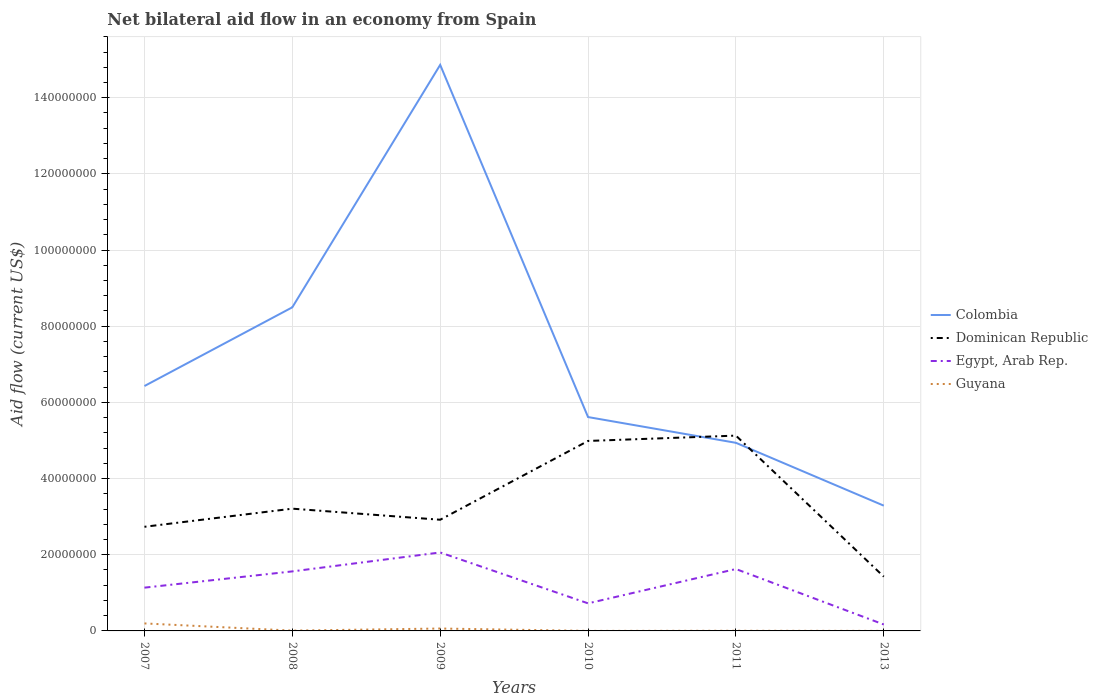How many different coloured lines are there?
Offer a very short reply. 4. Is the number of lines equal to the number of legend labels?
Make the answer very short. Yes. Across all years, what is the maximum net bilateral aid flow in Egypt, Arab Rep.?
Keep it short and to the point. 1.69e+06. What is the total net bilateral aid flow in Colombia in the graph?
Offer a very short reply. 3.56e+07. What is the difference between the highest and the second highest net bilateral aid flow in Egypt, Arab Rep.?
Keep it short and to the point. 1.89e+07. Is the net bilateral aid flow in Dominican Republic strictly greater than the net bilateral aid flow in Egypt, Arab Rep. over the years?
Make the answer very short. No. How many years are there in the graph?
Offer a terse response. 6. Are the values on the major ticks of Y-axis written in scientific E-notation?
Make the answer very short. No. Where does the legend appear in the graph?
Provide a succinct answer. Center right. How many legend labels are there?
Your answer should be compact. 4. How are the legend labels stacked?
Offer a very short reply. Vertical. What is the title of the graph?
Your answer should be compact. Net bilateral aid flow in an economy from Spain. Does "Sri Lanka" appear as one of the legend labels in the graph?
Provide a short and direct response. No. What is the label or title of the X-axis?
Provide a short and direct response. Years. What is the Aid flow (current US$) in Colombia in 2007?
Your answer should be compact. 6.43e+07. What is the Aid flow (current US$) of Dominican Republic in 2007?
Your answer should be compact. 2.73e+07. What is the Aid flow (current US$) of Egypt, Arab Rep. in 2007?
Your answer should be compact. 1.14e+07. What is the Aid flow (current US$) of Guyana in 2007?
Ensure brevity in your answer.  1.97e+06. What is the Aid flow (current US$) in Colombia in 2008?
Your answer should be very brief. 8.50e+07. What is the Aid flow (current US$) in Dominican Republic in 2008?
Your answer should be very brief. 3.21e+07. What is the Aid flow (current US$) of Egypt, Arab Rep. in 2008?
Make the answer very short. 1.56e+07. What is the Aid flow (current US$) of Colombia in 2009?
Your answer should be very brief. 1.49e+08. What is the Aid flow (current US$) in Dominican Republic in 2009?
Offer a very short reply. 2.92e+07. What is the Aid flow (current US$) in Egypt, Arab Rep. in 2009?
Your answer should be very brief. 2.06e+07. What is the Aid flow (current US$) in Guyana in 2009?
Offer a very short reply. 6.30e+05. What is the Aid flow (current US$) of Colombia in 2010?
Provide a short and direct response. 5.62e+07. What is the Aid flow (current US$) in Dominican Republic in 2010?
Your answer should be very brief. 4.99e+07. What is the Aid flow (current US$) in Egypt, Arab Rep. in 2010?
Ensure brevity in your answer.  7.24e+06. What is the Aid flow (current US$) in Colombia in 2011?
Ensure brevity in your answer.  4.94e+07. What is the Aid flow (current US$) of Dominican Republic in 2011?
Your answer should be very brief. 5.13e+07. What is the Aid flow (current US$) of Egypt, Arab Rep. in 2011?
Your answer should be very brief. 1.62e+07. What is the Aid flow (current US$) in Colombia in 2013?
Your answer should be compact. 3.29e+07. What is the Aid flow (current US$) of Dominican Republic in 2013?
Ensure brevity in your answer.  1.42e+07. What is the Aid flow (current US$) in Egypt, Arab Rep. in 2013?
Provide a succinct answer. 1.69e+06. What is the Aid flow (current US$) of Guyana in 2013?
Provide a short and direct response. 10000. Across all years, what is the maximum Aid flow (current US$) in Colombia?
Give a very brief answer. 1.49e+08. Across all years, what is the maximum Aid flow (current US$) in Dominican Republic?
Your answer should be compact. 5.13e+07. Across all years, what is the maximum Aid flow (current US$) of Egypt, Arab Rep.?
Ensure brevity in your answer.  2.06e+07. Across all years, what is the maximum Aid flow (current US$) of Guyana?
Offer a terse response. 1.97e+06. Across all years, what is the minimum Aid flow (current US$) in Colombia?
Your answer should be very brief. 3.29e+07. Across all years, what is the minimum Aid flow (current US$) of Dominican Republic?
Give a very brief answer. 1.42e+07. Across all years, what is the minimum Aid flow (current US$) in Egypt, Arab Rep.?
Ensure brevity in your answer.  1.69e+06. What is the total Aid flow (current US$) of Colombia in the graph?
Keep it short and to the point. 4.36e+08. What is the total Aid flow (current US$) in Dominican Republic in the graph?
Provide a succinct answer. 2.04e+08. What is the total Aid flow (current US$) in Egypt, Arab Rep. in the graph?
Keep it short and to the point. 7.28e+07. What is the total Aid flow (current US$) of Guyana in the graph?
Offer a terse response. 2.74e+06. What is the difference between the Aid flow (current US$) in Colombia in 2007 and that in 2008?
Provide a short and direct response. -2.07e+07. What is the difference between the Aid flow (current US$) of Dominican Republic in 2007 and that in 2008?
Provide a succinct answer. -4.76e+06. What is the difference between the Aid flow (current US$) of Egypt, Arab Rep. in 2007 and that in 2008?
Make the answer very short. -4.27e+06. What is the difference between the Aid flow (current US$) in Guyana in 2007 and that in 2008?
Provide a succinct answer. 1.89e+06. What is the difference between the Aid flow (current US$) in Colombia in 2007 and that in 2009?
Your response must be concise. -8.43e+07. What is the difference between the Aid flow (current US$) in Dominican Republic in 2007 and that in 2009?
Your response must be concise. -1.85e+06. What is the difference between the Aid flow (current US$) of Egypt, Arab Rep. in 2007 and that in 2009?
Offer a terse response. -9.24e+06. What is the difference between the Aid flow (current US$) in Guyana in 2007 and that in 2009?
Your response must be concise. 1.34e+06. What is the difference between the Aid flow (current US$) in Colombia in 2007 and that in 2010?
Offer a terse response. 8.15e+06. What is the difference between the Aid flow (current US$) of Dominican Republic in 2007 and that in 2010?
Your answer should be compact. -2.25e+07. What is the difference between the Aid flow (current US$) of Egypt, Arab Rep. in 2007 and that in 2010?
Offer a terse response. 4.12e+06. What is the difference between the Aid flow (current US$) of Guyana in 2007 and that in 2010?
Your answer should be very brief. 1.96e+06. What is the difference between the Aid flow (current US$) in Colombia in 2007 and that in 2011?
Keep it short and to the point. 1.49e+07. What is the difference between the Aid flow (current US$) of Dominican Republic in 2007 and that in 2011?
Your answer should be very brief. -2.39e+07. What is the difference between the Aid flow (current US$) of Egypt, Arab Rep. in 2007 and that in 2011?
Keep it short and to the point. -4.89e+06. What is the difference between the Aid flow (current US$) of Guyana in 2007 and that in 2011?
Provide a short and direct response. 1.93e+06. What is the difference between the Aid flow (current US$) in Colombia in 2007 and that in 2013?
Ensure brevity in your answer.  3.14e+07. What is the difference between the Aid flow (current US$) of Dominican Republic in 2007 and that in 2013?
Make the answer very short. 1.31e+07. What is the difference between the Aid flow (current US$) of Egypt, Arab Rep. in 2007 and that in 2013?
Provide a succinct answer. 9.67e+06. What is the difference between the Aid flow (current US$) of Guyana in 2007 and that in 2013?
Ensure brevity in your answer.  1.96e+06. What is the difference between the Aid flow (current US$) of Colombia in 2008 and that in 2009?
Your answer should be compact. -6.36e+07. What is the difference between the Aid flow (current US$) in Dominican Republic in 2008 and that in 2009?
Make the answer very short. 2.91e+06. What is the difference between the Aid flow (current US$) of Egypt, Arab Rep. in 2008 and that in 2009?
Offer a terse response. -4.97e+06. What is the difference between the Aid flow (current US$) of Guyana in 2008 and that in 2009?
Your response must be concise. -5.50e+05. What is the difference between the Aid flow (current US$) in Colombia in 2008 and that in 2010?
Provide a short and direct response. 2.88e+07. What is the difference between the Aid flow (current US$) of Dominican Republic in 2008 and that in 2010?
Your answer should be very brief. -1.78e+07. What is the difference between the Aid flow (current US$) of Egypt, Arab Rep. in 2008 and that in 2010?
Offer a terse response. 8.39e+06. What is the difference between the Aid flow (current US$) in Guyana in 2008 and that in 2010?
Provide a short and direct response. 7.00e+04. What is the difference between the Aid flow (current US$) in Colombia in 2008 and that in 2011?
Make the answer very short. 3.56e+07. What is the difference between the Aid flow (current US$) of Dominican Republic in 2008 and that in 2011?
Your response must be concise. -1.92e+07. What is the difference between the Aid flow (current US$) in Egypt, Arab Rep. in 2008 and that in 2011?
Offer a very short reply. -6.20e+05. What is the difference between the Aid flow (current US$) in Colombia in 2008 and that in 2013?
Keep it short and to the point. 5.21e+07. What is the difference between the Aid flow (current US$) in Dominican Republic in 2008 and that in 2013?
Give a very brief answer. 1.78e+07. What is the difference between the Aid flow (current US$) of Egypt, Arab Rep. in 2008 and that in 2013?
Give a very brief answer. 1.39e+07. What is the difference between the Aid flow (current US$) of Colombia in 2009 and that in 2010?
Your answer should be very brief. 9.25e+07. What is the difference between the Aid flow (current US$) of Dominican Republic in 2009 and that in 2010?
Your response must be concise. -2.07e+07. What is the difference between the Aid flow (current US$) in Egypt, Arab Rep. in 2009 and that in 2010?
Ensure brevity in your answer.  1.34e+07. What is the difference between the Aid flow (current US$) of Guyana in 2009 and that in 2010?
Offer a terse response. 6.20e+05. What is the difference between the Aid flow (current US$) of Colombia in 2009 and that in 2011?
Your answer should be compact. 9.92e+07. What is the difference between the Aid flow (current US$) in Dominican Republic in 2009 and that in 2011?
Provide a short and direct response. -2.21e+07. What is the difference between the Aid flow (current US$) of Egypt, Arab Rep. in 2009 and that in 2011?
Offer a very short reply. 4.35e+06. What is the difference between the Aid flow (current US$) of Guyana in 2009 and that in 2011?
Offer a very short reply. 5.90e+05. What is the difference between the Aid flow (current US$) of Colombia in 2009 and that in 2013?
Make the answer very short. 1.16e+08. What is the difference between the Aid flow (current US$) in Dominican Republic in 2009 and that in 2013?
Your answer should be compact. 1.49e+07. What is the difference between the Aid flow (current US$) of Egypt, Arab Rep. in 2009 and that in 2013?
Provide a short and direct response. 1.89e+07. What is the difference between the Aid flow (current US$) of Guyana in 2009 and that in 2013?
Your answer should be very brief. 6.20e+05. What is the difference between the Aid flow (current US$) of Colombia in 2010 and that in 2011?
Make the answer very short. 6.76e+06. What is the difference between the Aid flow (current US$) in Dominican Republic in 2010 and that in 2011?
Ensure brevity in your answer.  -1.40e+06. What is the difference between the Aid flow (current US$) of Egypt, Arab Rep. in 2010 and that in 2011?
Ensure brevity in your answer.  -9.01e+06. What is the difference between the Aid flow (current US$) in Guyana in 2010 and that in 2011?
Provide a short and direct response. -3.00e+04. What is the difference between the Aid flow (current US$) of Colombia in 2010 and that in 2013?
Your answer should be very brief. 2.33e+07. What is the difference between the Aid flow (current US$) in Dominican Republic in 2010 and that in 2013?
Give a very brief answer. 3.56e+07. What is the difference between the Aid flow (current US$) of Egypt, Arab Rep. in 2010 and that in 2013?
Keep it short and to the point. 5.55e+06. What is the difference between the Aid flow (current US$) of Colombia in 2011 and that in 2013?
Provide a short and direct response. 1.65e+07. What is the difference between the Aid flow (current US$) of Dominican Republic in 2011 and that in 2013?
Provide a short and direct response. 3.70e+07. What is the difference between the Aid flow (current US$) in Egypt, Arab Rep. in 2011 and that in 2013?
Your response must be concise. 1.46e+07. What is the difference between the Aid flow (current US$) of Colombia in 2007 and the Aid flow (current US$) of Dominican Republic in 2008?
Offer a very short reply. 3.22e+07. What is the difference between the Aid flow (current US$) of Colombia in 2007 and the Aid flow (current US$) of Egypt, Arab Rep. in 2008?
Your answer should be very brief. 4.87e+07. What is the difference between the Aid flow (current US$) of Colombia in 2007 and the Aid flow (current US$) of Guyana in 2008?
Offer a terse response. 6.42e+07. What is the difference between the Aid flow (current US$) of Dominican Republic in 2007 and the Aid flow (current US$) of Egypt, Arab Rep. in 2008?
Keep it short and to the point. 1.17e+07. What is the difference between the Aid flow (current US$) of Dominican Republic in 2007 and the Aid flow (current US$) of Guyana in 2008?
Your answer should be very brief. 2.73e+07. What is the difference between the Aid flow (current US$) of Egypt, Arab Rep. in 2007 and the Aid flow (current US$) of Guyana in 2008?
Offer a terse response. 1.13e+07. What is the difference between the Aid flow (current US$) in Colombia in 2007 and the Aid flow (current US$) in Dominican Republic in 2009?
Make the answer very short. 3.51e+07. What is the difference between the Aid flow (current US$) of Colombia in 2007 and the Aid flow (current US$) of Egypt, Arab Rep. in 2009?
Offer a terse response. 4.37e+07. What is the difference between the Aid flow (current US$) in Colombia in 2007 and the Aid flow (current US$) in Guyana in 2009?
Your answer should be very brief. 6.37e+07. What is the difference between the Aid flow (current US$) of Dominican Republic in 2007 and the Aid flow (current US$) of Egypt, Arab Rep. in 2009?
Offer a terse response. 6.74e+06. What is the difference between the Aid flow (current US$) in Dominican Republic in 2007 and the Aid flow (current US$) in Guyana in 2009?
Make the answer very short. 2.67e+07. What is the difference between the Aid flow (current US$) in Egypt, Arab Rep. in 2007 and the Aid flow (current US$) in Guyana in 2009?
Offer a very short reply. 1.07e+07. What is the difference between the Aid flow (current US$) of Colombia in 2007 and the Aid flow (current US$) of Dominican Republic in 2010?
Offer a very short reply. 1.44e+07. What is the difference between the Aid flow (current US$) in Colombia in 2007 and the Aid flow (current US$) in Egypt, Arab Rep. in 2010?
Ensure brevity in your answer.  5.71e+07. What is the difference between the Aid flow (current US$) in Colombia in 2007 and the Aid flow (current US$) in Guyana in 2010?
Keep it short and to the point. 6.43e+07. What is the difference between the Aid flow (current US$) in Dominican Republic in 2007 and the Aid flow (current US$) in Egypt, Arab Rep. in 2010?
Keep it short and to the point. 2.01e+07. What is the difference between the Aid flow (current US$) of Dominican Republic in 2007 and the Aid flow (current US$) of Guyana in 2010?
Give a very brief answer. 2.73e+07. What is the difference between the Aid flow (current US$) of Egypt, Arab Rep. in 2007 and the Aid flow (current US$) of Guyana in 2010?
Provide a succinct answer. 1.14e+07. What is the difference between the Aid flow (current US$) of Colombia in 2007 and the Aid flow (current US$) of Dominican Republic in 2011?
Your response must be concise. 1.30e+07. What is the difference between the Aid flow (current US$) in Colombia in 2007 and the Aid flow (current US$) in Egypt, Arab Rep. in 2011?
Offer a very short reply. 4.80e+07. What is the difference between the Aid flow (current US$) of Colombia in 2007 and the Aid flow (current US$) of Guyana in 2011?
Your answer should be compact. 6.43e+07. What is the difference between the Aid flow (current US$) of Dominican Republic in 2007 and the Aid flow (current US$) of Egypt, Arab Rep. in 2011?
Offer a terse response. 1.11e+07. What is the difference between the Aid flow (current US$) in Dominican Republic in 2007 and the Aid flow (current US$) in Guyana in 2011?
Offer a very short reply. 2.73e+07. What is the difference between the Aid flow (current US$) in Egypt, Arab Rep. in 2007 and the Aid flow (current US$) in Guyana in 2011?
Ensure brevity in your answer.  1.13e+07. What is the difference between the Aid flow (current US$) in Colombia in 2007 and the Aid flow (current US$) in Dominican Republic in 2013?
Offer a very short reply. 5.00e+07. What is the difference between the Aid flow (current US$) in Colombia in 2007 and the Aid flow (current US$) in Egypt, Arab Rep. in 2013?
Make the answer very short. 6.26e+07. What is the difference between the Aid flow (current US$) of Colombia in 2007 and the Aid flow (current US$) of Guyana in 2013?
Provide a succinct answer. 6.43e+07. What is the difference between the Aid flow (current US$) of Dominican Republic in 2007 and the Aid flow (current US$) of Egypt, Arab Rep. in 2013?
Provide a succinct answer. 2.56e+07. What is the difference between the Aid flow (current US$) in Dominican Republic in 2007 and the Aid flow (current US$) in Guyana in 2013?
Give a very brief answer. 2.73e+07. What is the difference between the Aid flow (current US$) of Egypt, Arab Rep. in 2007 and the Aid flow (current US$) of Guyana in 2013?
Ensure brevity in your answer.  1.14e+07. What is the difference between the Aid flow (current US$) of Colombia in 2008 and the Aid flow (current US$) of Dominican Republic in 2009?
Your response must be concise. 5.58e+07. What is the difference between the Aid flow (current US$) in Colombia in 2008 and the Aid flow (current US$) in Egypt, Arab Rep. in 2009?
Give a very brief answer. 6.44e+07. What is the difference between the Aid flow (current US$) of Colombia in 2008 and the Aid flow (current US$) of Guyana in 2009?
Offer a very short reply. 8.43e+07. What is the difference between the Aid flow (current US$) in Dominican Republic in 2008 and the Aid flow (current US$) in Egypt, Arab Rep. in 2009?
Provide a succinct answer. 1.15e+07. What is the difference between the Aid flow (current US$) in Dominican Republic in 2008 and the Aid flow (current US$) in Guyana in 2009?
Ensure brevity in your answer.  3.15e+07. What is the difference between the Aid flow (current US$) of Egypt, Arab Rep. in 2008 and the Aid flow (current US$) of Guyana in 2009?
Provide a short and direct response. 1.50e+07. What is the difference between the Aid flow (current US$) of Colombia in 2008 and the Aid flow (current US$) of Dominican Republic in 2010?
Your answer should be compact. 3.51e+07. What is the difference between the Aid flow (current US$) of Colombia in 2008 and the Aid flow (current US$) of Egypt, Arab Rep. in 2010?
Offer a very short reply. 7.77e+07. What is the difference between the Aid flow (current US$) of Colombia in 2008 and the Aid flow (current US$) of Guyana in 2010?
Make the answer very short. 8.50e+07. What is the difference between the Aid flow (current US$) in Dominican Republic in 2008 and the Aid flow (current US$) in Egypt, Arab Rep. in 2010?
Your answer should be very brief. 2.49e+07. What is the difference between the Aid flow (current US$) in Dominican Republic in 2008 and the Aid flow (current US$) in Guyana in 2010?
Give a very brief answer. 3.21e+07. What is the difference between the Aid flow (current US$) of Egypt, Arab Rep. in 2008 and the Aid flow (current US$) of Guyana in 2010?
Provide a short and direct response. 1.56e+07. What is the difference between the Aid flow (current US$) of Colombia in 2008 and the Aid flow (current US$) of Dominican Republic in 2011?
Make the answer very short. 3.37e+07. What is the difference between the Aid flow (current US$) in Colombia in 2008 and the Aid flow (current US$) in Egypt, Arab Rep. in 2011?
Keep it short and to the point. 6.87e+07. What is the difference between the Aid flow (current US$) in Colombia in 2008 and the Aid flow (current US$) in Guyana in 2011?
Your answer should be compact. 8.49e+07. What is the difference between the Aid flow (current US$) in Dominican Republic in 2008 and the Aid flow (current US$) in Egypt, Arab Rep. in 2011?
Ensure brevity in your answer.  1.58e+07. What is the difference between the Aid flow (current US$) in Dominican Republic in 2008 and the Aid flow (current US$) in Guyana in 2011?
Give a very brief answer. 3.21e+07. What is the difference between the Aid flow (current US$) of Egypt, Arab Rep. in 2008 and the Aid flow (current US$) of Guyana in 2011?
Your answer should be compact. 1.56e+07. What is the difference between the Aid flow (current US$) in Colombia in 2008 and the Aid flow (current US$) in Dominican Republic in 2013?
Offer a very short reply. 7.07e+07. What is the difference between the Aid flow (current US$) of Colombia in 2008 and the Aid flow (current US$) of Egypt, Arab Rep. in 2013?
Ensure brevity in your answer.  8.33e+07. What is the difference between the Aid flow (current US$) of Colombia in 2008 and the Aid flow (current US$) of Guyana in 2013?
Keep it short and to the point. 8.50e+07. What is the difference between the Aid flow (current US$) of Dominican Republic in 2008 and the Aid flow (current US$) of Egypt, Arab Rep. in 2013?
Offer a very short reply. 3.04e+07. What is the difference between the Aid flow (current US$) in Dominican Republic in 2008 and the Aid flow (current US$) in Guyana in 2013?
Give a very brief answer. 3.21e+07. What is the difference between the Aid flow (current US$) in Egypt, Arab Rep. in 2008 and the Aid flow (current US$) in Guyana in 2013?
Keep it short and to the point. 1.56e+07. What is the difference between the Aid flow (current US$) in Colombia in 2009 and the Aid flow (current US$) in Dominican Republic in 2010?
Your answer should be very brief. 9.87e+07. What is the difference between the Aid flow (current US$) of Colombia in 2009 and the Aid flow (current US$) of Egypt, Arab Rep. in 2010?
Ensure brevity in your answer.  1.41e+08. What is the difference between the Aid flow (current US$) of Colombia in 2009 and the Aid flow (current US$) of Guyana in 2010?
Your response must be concise. 1.49e+08. What is the difference between the Aid flow (current US$) in Dominican Republic in 2009 and the Aid flow (current US$) in Egypt, Arab Rep. in 2010?
Provide a short and direct response. 2.20e+07. What is the difference between the Aid flow (current US$) in Dominican Republic in 2009 and the Aid flow (current US$) in Guyana in 2010?
Make the answer very short. 2.92e+07. What is the difference between the Aid flow (current US$) in Egypt, Arab Rep. in 2009 and the Aid flow (current US$) in Guyana in 2010?
Offer a very short reply. 2.06e+07. What is the difference between the Aid flow (current US$) in Colombia in 2009 and the Aid flow (current US$) in Dominican Republic in 2011?
Provide a short and direct response. 9.73e+07. What is the difference between the Aid flow (current US$) in Colombia in 2009 and the Aid flow (current US$) in Egypt, Arab Rep. in 2011?
Ensure brevity in your answer.  1.32e+08. What is the difference between the Aid flow (current US$) of Colombia in 2009 and the Aid flow (current US$) of Guyana in 2011?
Provide a succinct answer. 1.49e+08. What is the difference between the Aid flow (current US$) of Dominican Republic in 2009 and the Aid flow (current US$) of Egypt, Arab Rep. in 2011?
Your answer should be compact. 1.29e+07. What is the difference between the Aid flow (current US$) of Dominican Republic in 2009 and the Aid flow (current US$) of Guyana in 2011?
Your answer should be compact. 2.92e+07. What is the difference between the Aid flow (current US$) of Egypt, Arab Rep. in 2009 and the Aid flow (current US$) of Guyana in 2011?
Your answer should be very brief. 2.06e+07. What is the difference between the Aid flow (current US$) of Colombia in 2009 and the Aid flow (current US$) of Dominican Republic in 2013?
Your answer should be compact. 1.34e+08. What is the difference between the Aid flow (current US$) in Colombia in 2009 and the Aid flow (current US$) in Egypt, Arab Rep. in 2013?
Your answer should be very brief. 1.47e+08. What is the difference between the Aid flow (current US$) in Colombia in 2009 and the Aid flow (current US$) in Guyana in 2013?
Provide a short and direct response. 1.49e+08. What is the difference between the Aid flow (current US$) in Dominican Republic in 2009 and the Aid flow (current US$) in Egypt, Arab Rep. in 2013?
Make the answer very short. 2.75e+07. What is the difference between the Aid flow (current US$) in Dominican Republic in 2009 and the Aid flow (current US$) in Guyana in 2013?
Give a very brief answer. 2.92e+07. What is the difference between the Aid flow (current US$) in Egypt, Arab Rep. in 2009 and the Aid flow (current US$) in Guyana in 2013?
Provide a short and direct response. 2.06e+07. What is the difference between the Aid flow (current US$) in Colombia in 2010 and the Aid flow (current US$) in Dominican Republic in 2011?
Make the answer very short. 4.87e+06. What is the difference between the Aid flow (current US$) of Colombia in 2010 and the Aid flow (current US$) of Egypt, Arab Rep. in 2011?
Your response must be concise. 3.99e+07. What is the difference between the Aid flow (current US$) in Colombia in 2010 and the Aid flow (current US$) in Guyana in 2011?
Provide a succinct answer. 5.61e+07. What is the difference between the Aid flow (current US$) in Dominican Republic in 2010 and the Aid flow (current US$) in Egypt, Arab Rep. in 2011?
Ensure brevity in your answer.  3.36e+07. What is the difference between the Aid flow (current US$) of Dominican Republic in 2010 and the Aid flow (current US$) of Guyana in 2011?
Your answer should be very brief. 4.98e+07. What is the difference between the Aid flow (current US$) in Egypt, Arab Rep. in 2010 and the Aid flow (current US$) in Guyana in 2011?
Provide a short and direct response. 7.20e+06. What is the difference between the Aid flow (current US$) of Colombia in 2010 and the Aid flow (current US$) of Dominican Republic in 2013?
Offer a very short reply. 4.19e+07. What is the difference between the Aid flow (current US$) in Colombia in 2010 and the Aid flow (current US$) in Egypt, Arab Rep. in 2013?
Your answer should be compact. 5.45e+07. What is the difference between the Aid flow (current US$) of Colombia in 2010 and the Aid flow (current US$) of Guyana in 2013?
Your answer should be compact. 5.61e+07. What is the difference between the Aid flow (current US$) in Dominican Republic in 2010 and the Aid flow (current US$) in Egypt, Arab Rep. in 2013?
Keep it short and to the point. 4.82e+07. What is the difference between the Aid flow (current US$) in Dominican Republic in 2010 and the Aid flow (current US$) in Guyana in 2013?
Your answer should be compact. 4.99e+07. What is the difference between the Aid flow (current US$) in Egypt, Arab Rep. in 2010 and the Aid flow (current US$) in Guyana in 2013?
Your answer should be very brief. 7.23e+06. What is the difference between the Aid flow (current US$) of Colombia in 2011 and the Aid flow (current US$) of Dominican Republic in 2013?
Your answer should be compact. 3.51e+07. What is the difference between the Aid flow (current US$) of Colombia in 2011 and the Aid flow (current US$) of Egypt, Arab Rep. in 2013?
Ensure brevity in your answer.  4.77e+07. What is the difference between the Aid flow (current US$) of Colombia in 2011 and the Aid flow (current US$) of Guyana in 2013?
Your response must be concise. 4.94e+07. What is the difference between the Aid flow (current US$) in Dominican Republic in 2011 and the Aid flow (current US$) in Egypt, Arab Rep. in 2013?
Your response must be concise. 4.96e+07. What is the difference between the Aid flow (current US$) in Dominican Republic in 2011 and the Aid flow (current US$) in Guyana in 2013?
Your answer should be very brief. 5.13e+07. What is the difference between the Aid flow (current US$) in Egypt, Arab Rep. in 2011 and the Aid flow (current US$) in Guyana in 2013?
Offer a terse response. 1.62e+07. What is the average Aid flow (current US$) of Colombia per year?
Provide a succinct answer. 7.27e+07. What is the average Aid flow (current US$) in Dominican Republic per year?
Provide a succinct answer. 3.40e+07. What is the average Aid flow (current US$) in Egypt, Arab Rep. per year?
Keep it short and to the point. 1.21e+07. What is the average Aid flow (current US$) in Guyana per year?
Provide a short and direct response. 4.57e+05. In the year 2007, what is the difference between the Aid flow (current US$) of Colombia and Aid flow (current US$) of Dominican Republic?
Provide a succinct answer. 3.70e+07. In the year 2007, what is the difference between the Aid flow (current US$) in Colombia and Aid flow (current US$) in Egypt, Arab Rep.?
Your response must be concise. 5.29e+07. In the year 2007, what is the difference between the Aid flow (current US$) of Colombia and Aid flow (current US$) of Guyana?
Your answer should be very brief. 6.23e+07. In the year 2007, what is the difference between the Aid flow (current US$) in Dominican Republic and Aid flow (current US$) in Egypt, Arab Rep.?
Offer a terse response. 1.60e+07. In the year 2007, what is the difference between the Aid flow (current US$) of Dominican Republic and Aid flow (current US$) of Guyana?
Ensure brevity in your answer.  2.54e+07. In the year 2007, what is the difference between the Aid flow (current US$) in Egypt, Arab Rep. and Aid flow (current US$) in Guyana?
Provide a succinct answer. 9.39e+06. In the year 2008, what is the difference between the Aid flow (current US$) in Colombia and Aid flow (current US$) in Dominican Republic?
Make the answer very short. 5.29e+07. In the year 2008, what is the difference between the Aid flow (current US$) of Colombia and Aid flow (current US$) of Egypt, Arab Rep.?
Provide a succinct answer. 6.93e+07. In the year 2008, what is the difference between the Aid flow (current US$) of Colombia and Aid flow (current US$) of Guyana?
Your answer should be compact. 8.49e+07. In the year 2008, what is the difference between the Aid flow (current US$) of Dominican Republic and Aid flow (current US$) of Egypt, Arab Rep.?
Your answer should be compact. 1.65e+07. In the year 2008, what is the difference between the Aid flow (current US$) in Dominican Republic and Aid flow (current US$) in Guyana?
Provide a short and direct response. 3.20e+07. In the year 2008, what is the difference between the Aid flow (current US$) in Egypt, Arab Rep. and Aid flow (current US$) in Guyana?
Your answer should be very brief. 1.56e+07. In the year 2009, what is the difference between the Aid flow (current US$) of Colombia and Aid flow (current US$) of Dominican Republic?
Offer a terse response. 1.19e+08. In the year 2009, what is the difference between the Aid flow (current US$) of Colombia and Aid flow (current US$) of Egypt, Arab Rep.?
Your answer should be very brief. 1.28e+08. In the year 2009, what is the difference between the Aid flow (current US$) in Colombia and Aid flow (current US$) in Guyana?
Your answer should be very brief. 1.48e+08. In the year 2009, what is the difference between the Aid flow (current US$) in Dominican Republic and Aid flow (current US$) in Egypt, Arab Rep.?
Offer a terse response. 8.59e+06. In the year 2009, what is the difference between the Aid flow (current US$) of Dominican Republic and Aid flow (current US$) of Guyana?
Keep it short and to the point. 2.86e+07. In the year 2009, what is the difference between the Aid flow (current US$) in Egypt, Arab Rep. and Aid flow (current US$) in Guyana?
Your answer should be very brief. 2.00e+07. In the year 2010, what is the difference between the Aid flow (current US$) of Colombia and Aid flow (current US$) of Dominican Republic?
Offer a very short reply. 6.27e+06. In the year 2010, what is the difference between the Aid flow (current US$) in Colombia and Aid flow (current US$) in Egypt, Arab Rep.?
Provide a short and direct response. 4.89e+07. In the year 2010, what is the difference between the Aid flow (current US$) in Colombia and Aid flow (current US$) in Guyana?
Give a very brief answer. 5.61e+07. In the year 2010, what is the difference between the Aid flow (current US$) of Dominican Republic and Aid flow (current US$) of Egypt, Arab Rep.?
Ensure brevity in your answer.  4.26e+07. In the year 2010, what is the difference between the Aid flow (current US$) in Dominican Republic and Aid flow (current US$) in Guyana?
Provide a succinct answer. 4.99e+07. In the year 2010, what is the difference between the Aid flow (current US$) of Egypt, Arab Rep. and Aid flow (current US$) of Guyana?
Give a very brief answer. 7.23e+06. In the year 2011, what is the difference between the Aid flow (current US$) of Colombia and Aid flow (current US$) of Dominican Republic?
Offer a terse response. -1.89e+06. In the year 2011, what is the difference between the Aid flow (current US$) of Colombia and Aid flow (current US$) of Egypt, Arab Rep.?
Your answer should be very brief. 3.31e+07. In the year 2011, what is the difference between the Aid flow (current US$) of Colombia and Aid flow (current US$) of Guyana?
Offer a very short reply. 4.94e+07. In the year 2011, what is the difference between the Aid flow (current US$) of Dominican Republic and Aid flow (current US$) of Egypt, Arab Rep.?
Your answer should be compact. 3.50e+07. In the year 2011, what is the difference between the Aid flow (current US$) of Dominican Republic and Aid flow (current US$) of Guyana?
Give a very brief answer. 5.12e+07. In the year 2011, what is the difference between the Aid flow (current US$) of Egypt, Arab Rep. and Aid flow (current US$) of Guyana?
Provide a short and direct response. 1.62e+07. In the year 2013, what is the difference between the Aid flow (current US$) in Colombia and Aid flow (current US$) in Dominican Republic?
Provide a succinct answer. 1.86e+07. In the year 2013, what is the difference between the Aid flow (current US$) in Colombia and Aid flow (current US$) in Egypt, Arab Rep.?
Provide a short and direct response. 3.12e+07. In the year 2013, what is the difference between the Aid flow (current US$) of Colombia and Aid flow (current US$) of Guyana?
Make the answer very short. 3.29e+07. In the year 2013, what is the difference between the Aid flow (current US$) in Dominican Republic and Aid flow (current US$) in Egypt, Arab Rep.?
Offer a terse response. 1.26e+07. In the year 2013, what is the difference between the Aid flow (current US$) of Dominican Republic and Aid flow (current US$) of Guyana?
Offer a very short reply. 1.42e+07. In the year 2013, what is the difference between the Aid flow (current US$) of Egypt, Arab Rep. and Aid flow (current US$) of Guyana?
Your response must be concise. 1.68e+06. What is the ratio of the Aid flow (current US$) in Colombia in 2007 to that in 2008?
Offer a terse response. 0.76. What is the ratio of the Aid flow (current US$) in Dominican Republic in 2007 to that in 2008?
Your response must be concise. 0.85. What is the ratio of the Aid flow (current US$) in Egypt, Arab Rep. in 2007 to that in 2008?
Keep it short and to the point. 0.73. What is the ratio of the Aid flow (current US$) in Guyana in 2007 to that in 2008?
Provide a succinct answer. 24.62. What is the ratio of the Aid flow (current US$) in Colombia in 2007 to that in 2009?
Your response must be concise. 0.43. What is the ratio of the Aid flow (current US$) in Dominican Republic in 2007 to that in 2009?
Ensure brevity in your answer.  0.94. What is the ratio of the Aid flow (current US$) in Egypt, Arab Rep. in 2007 to that in 2009?
Offer a terse response. 0.55. What is the ratio of the Aid flow (current US$) in Guyana in 2007 to that in 2009?
Offer a very short reply. 3.13. What is the ratio of the Aid flow (current US$) in Colombia in 2007 to that in 2010?
Give a very brief answer. 1.15. What is the ratio of the Aid flow (current US$) in Dominican Republic in 2007 to that in 2010?
Offer a terse response. 0.55. What is the ratio of the Aid flow (current US$) in Egypt, Arab Rep. in 2007 to that in 2010?
Your answer should be compact. 1.57. What is the ratio of the Aid flow (current US$) in Guyana in 2007 to that in 2010?
Provide a succinct answer. 197. What is the ratio of the Aid flow (current US$) in Colombia in 2007 to that in 2011?
Give a very brief answer. 1.3. What is the ratio of the Aid flow (current US$) of Dominican Republic in 2007 to that in 2011?
Ensure brevity in your answer.  0.53. What is the ratio of the Aid flow (current US$) in Egypt, Arab Rep. in 2007 to that in 2011?
Offer a terse response. 0.7. What is the ratio of the Aid flow (current US$) of Guyana in 2007 to that in 2011?
Provide a short and direct response. 49.25. What is the ratio of the Aid flow (current US$) in Colombia in 2007 to that in 2013?
Provide a short and direct response. 1.96. What is the ratio of the Aid flow (current US$) in Dominican Republic in 2007 to that in 2013?
Ensure brevity in your answer.  1.92. What is the ratio of the Aid flow (current US$) of Egypt, Arab Rep. in 2007 to that in 2013?
Provide a short and direct response. 6.72. What is the ratio of the Aid flow (current US$) in Guyana in 2007 to that in 2013?
Your answer should be very brief. 197. What is the ratio of the Aid flow (current US$) in Colombia in 2008 to that in 2009?
Make the answer very short. 0.57. What is the ratio of the Aid flow (current US$) of Dominican Republic in 2008 to that in 2009?
Offer a very short reply. 1.1. What is the ratio of the Aid flow (current US$) in Egypt, Arab Rep. in 2008 to that in 2009?
Your answer should be very brief. 0.76. What is the ratio of the Aid flow (current US$) of Guyana in 2008 to that in 2009?
Your answer should be very brief. 0.13. What is the ratio of the Aid flow (current US$) of Colombia in 2008 to that in 2010?
Ensure brevity in your answer.  1.51. What is the ratio of the Aid flow (current US$) of Dominican Republic in 2008 to that in 2010?
Offer a terse response. 0.64. What is the ratio of the Aid flow (current US$) in Egypt, Arab Rep. in 2008 to that in 2010?
Offer a very short reply. 2.16. What is the ratio of the Aid flow (current US$) in Guyana in 2008 to that in 2010?
Offer a very short reply. 8. What is the ratio of the Aid flow (current US$) of Colombia in 2008 to that in 2011?
Provide a succinct answer. 1.72. What is the ratio of the Aid flow (current US$) in Dominican Republic in 2008 to that in 2011?
Ensure brevity in your answer.  0.63. What is the ratio of the Aid flow (current US$) in Egypt, Arab Rep. in 2008 to that in 2011?
Your answer should be very brief. 0.96. What is the ratio of the Aid flow (current US$) in Guyana in 2008 to that in 2011?
Keep it short and to the point. 2. What is the ratio of the Aid flow (current US$) in Colombia in 2008 to that in 2013?
Offer a very short reply. 2.58. What is the ratio of the Aid flow (current US$) in Dominican Republic in 2008 to that in 2013?
Provide a succinct answer. 2.25. What is the ratio of the Aid flow (current US$) in Egypt, Arab Rep. in 2008 to that in 2013?
Provide a succinct answer. 9.25. What is the ratio of the Aid flow (current US$) in Guyana in 2008 to that in 2013?
Provide a succinct answer. 8. What is the ratio of the Aid flow (current US$) in Colombia in 2009 to that in 2010?
Your answer should be very brief. 2.65. What is the ratio of the Aid flow (current US$) of Dominican Republic in 2009 to that in 2010?
Provide a succinct answer. 0.59. What is the ratio of the Aid flow (current US$) of Egypt, Arab Rep. in 2009 to that in 2010?
Provide a short and direct response. 2.85. What is the ratio of the Aid flow (current US$) in Guyana in 2009 to that in 2010?
Keep it short and to the point. 63. What is the ratio of the Aid flow (current US$) of Colombia in 2009 to that in 2011?
Your answer should be very brief. 3.01. What is the ratio of the Aid flow (current US$) in Dominican Republic in 2009 to that in 2011?
Give a very brief answer. 0.57. What is the ratio of the Aid flow (current US$) in Egypt, Arab Rep. in 2009 to that in 2011?
Make the answer very short. 1.27. What is the ratio of the Aid flow (current US$) in Guyana in 2009 to that in 2011?
Your answer should be very brief. 15.75. What is the ratio of the Aid flow (current US$) of Colombia in 2009 to that in 2013?
Your answer should be compact. 4.52. What is the ratio of the Aid flow (current US$) in Dominican Republic in 2009 to that in 2013?
Make the answer very short. 2.05. What is the ratio of the Aid flow (current US$) in Egypt, Arab Rep. in 2009 to that in 2013?
Ensure brevity in your answer.  12.19. What is the ratio of the Aid flow (current US$) of Colombia in 2010 to that in 2011?
Provide a short and direct response. 1.14. What is the ratio of the Aid flow (current US$) in Dominican Republic in 2010 to that in 2011?
Your response must be concise. 0.97. What is the ratio of the Aid flow (current US$) in Egypt, Arab Rep. in 2010 to that in 2011?
Provide a succinct answer. 0.45. What is the ratio of the Aid flow (current US$) in Colombia in 2010 to that in 2013?
Provide a succinct answer. 1.71. What is the ratio of the Aid flow (current US$) of Dominican Republic in 2010 to that in 2013?
Offer a very short reply. 3.5. What is the ratio of the Aid flow (current US$) of Egypt, Arab Rep. in 2010 to that in 2013?
Your response must be concise. 4.28. What is the ratio of the Aid flow (current US$) of Guyana in 2010 to that in 2013?
Keep it short and to the point. 1. What is the ratio of the Aid flow (current US$) of Colombia in 2011 to that in 2013?
Offer a very short reply. 1.5. What is the ratio of the Aid flow (current US$) of Dominican Republic in 2011 to that in 2013?
Offer a terse response. 3.6. What is the ratio of the Aid flow (current US$) in Egypt, Arab Rep. in 2011 to that in 2013?
Provide a short and direct response. 9.62. What is the difference between the highest and the second highest Aid flow (current US$) in Colombia?
Provide a short and direct response. 6.36e+07. What is the difference between the highest and the second highest Aid flow (current US$) in Dominican Republic?
Keep it short and to the point. 1.40e+06. What is the difference between the highest and the second highest Aid flow (current US$) of Egypt, Arab Rep.?
Your answer should be compact. 4.35e+06. What is the difference between the highest and the second highest Aid flow (current US$) in Guyana?
Keep it short and to the point. 1.34e+06. What is the difference between the highest and the lowest Aid flow (current US$) of Colombia?
Keep it short and to the point. 1.16e+08. What is the difference between the highest and the lowest Aid flow (current US$) in Dominican Republic?
Offer a terse response. 3.70e+07. What is the difference between the highest and the lowest Aid flow (current US$) of Egypt, Arab Rep.?
Provide a succinct answer. 1.89e+07. What is the difference between the highest and the lowest Aid flow (current US$) of Guyana?
Your answer should be very brief. 1.96e+06. 